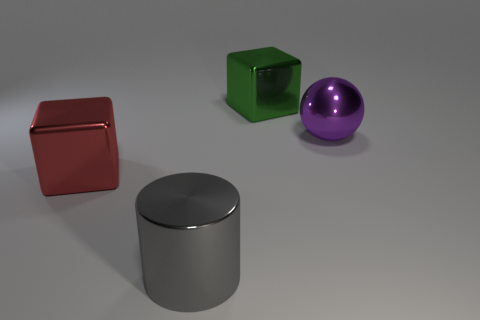Add 3 large cyan matte spheres. How many objects exist? 7 Subtract all cylinders. How many objects are left? 3 Add 1 cubes. How many cubes are left? 3 Add 4 gray objects. How many gray objects exist? 5 Subtract 0 blue cubes. How many objects are left? 4 Subtract all balls. Subtract all blocks. How many objects are left? 1 